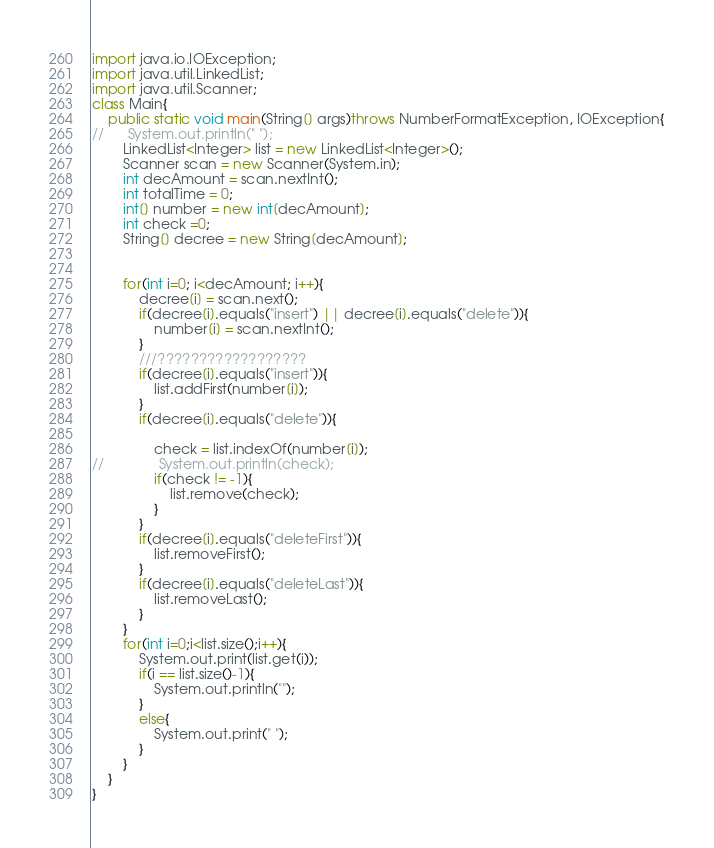Convert code to text. <code><loc_0><loc_0><loc_500><loc_500><_Java_>import java.io.IOException;
import java.util.LinkedList;
import java.util.Scanner;
class Main{
	public static void main(String[] args)throws NumberFormatException, IOException{
//		System.out.println(" ");
		LinkedList<Integer> list = new LinkedList<Integer>();
		Scanner scan = new Scanner(System.in);
		int decAmount = scan.nextInt();
		int totalTime = 0;
		int[] number = new int[decAmount];	
		int check =0;
		String[] decree = new String[decAmount];
		

		for(int i=0; i<decAmount; i++){
			decree[i] = scan.next();
			if(decree[i].equals("insert") || decree[i].equals("delete")){
				number[i] = scan.nextInt();
			}
			///??????????????????
			if(decree[i].equals("insert")){
				list.addFirst(number[i]);
			}
			if(decree[i].equals("delete")){
				
				check = list.indexOf(number[i]);
//				System.out.println(check);
				if(check != -1){
					list.remove(check);
				}
			}
			if(decree[i].equals("deleteFirst")){
				list.removeFirst();
			}
			if(decree[i].equals("deleteLast")){
				list.removeLast();
			}
		}
		for(int i=0;i<list.size();i++){
			System.out.print(list.get(i));
			if(i == list.size()-1){
				System.out.println("");
			}
			else{
				System.out.print(" ");
			}
		}
	}
}</code> 